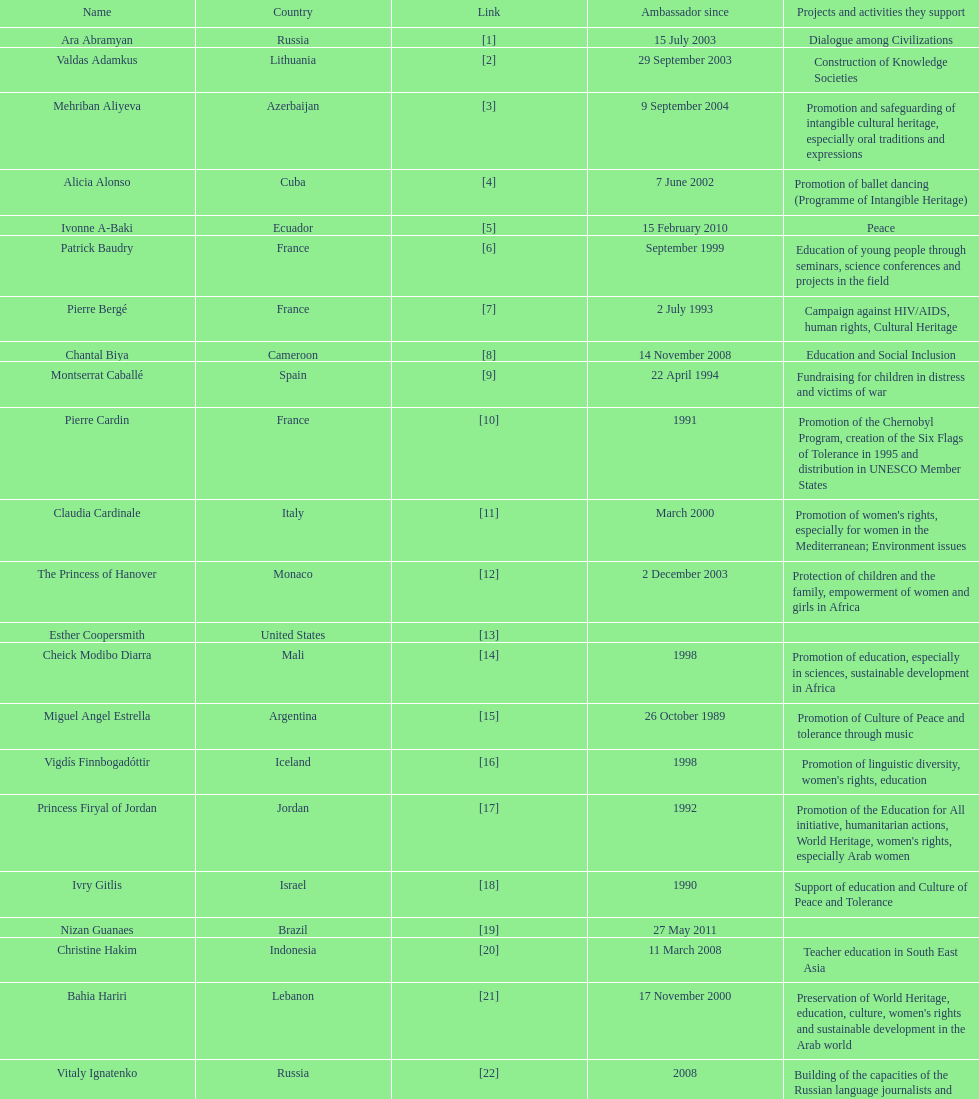Which unesco goodwill ambassador is most known for the promotion of the chernobyl program? Pierre Cardin. 